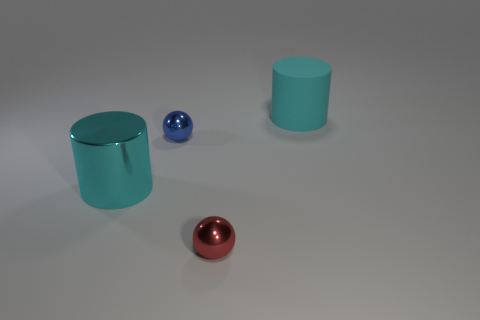Are there any other metallic things that have the same size as the cyan metallic object?
Provide a succinct answer. No. Do the cyan cylinder in front of the blue metallic object and the tiny red thing have the same size?
Keep it short and to the point. No. The rubber cylinder has what size?
Keep it short and to the point. Large. The large cylinder that is in front of the cyan object behind the cyan thing left of the large rubber object is what color?
Provide a succinct answer. Cyan. Do the cylinder behind the big cyan metallic cylinder and the big shiny thing have the same color?
Your answer should be very brief. Yes. What number of big objects are both behind the tiny blue object and in front of the small blue shiny object?
Keep it short and to the point. 0. There is another metallic object that is the same shape as the blue shiny object; what size is it?
Make the answer very short. Small. There is a cylinder that is left of the small thing that is to the left of the small red ball; what number of cyan cylinders are right of it?
Give a very brief answer. 1. There is a metallic object that is behind the cyan cylinder on the left side of the large cyan rubber cylinder; what color is it?
Provide a short and direct response. Blue. What number of other objects are there of the same material as the tiny red object?
Make the answer very short. 2. 